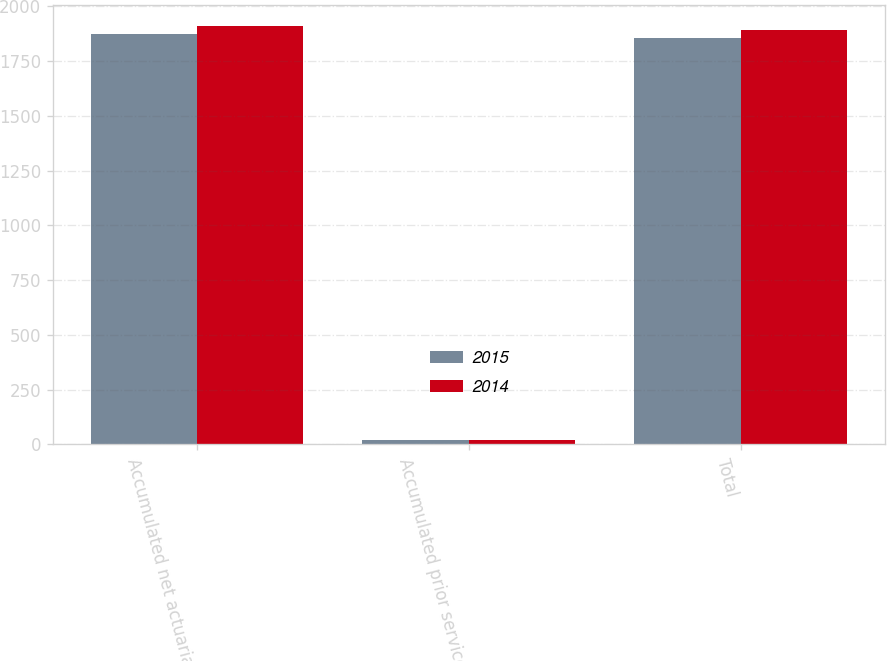Convert chart. <chart><loc_0><loc_0><loc_500><loc_500><stacked_bar_chart><ecel><fcel>Accumulated net actuarial<fcel>Accumulated prior service<fcel>Total<nl><fcel>2015<fcel>1872<fcel>18<fcel>1854<nl><fcel>2014<fcel>1910<fcel>20<fcel>1890<nl></chart> 